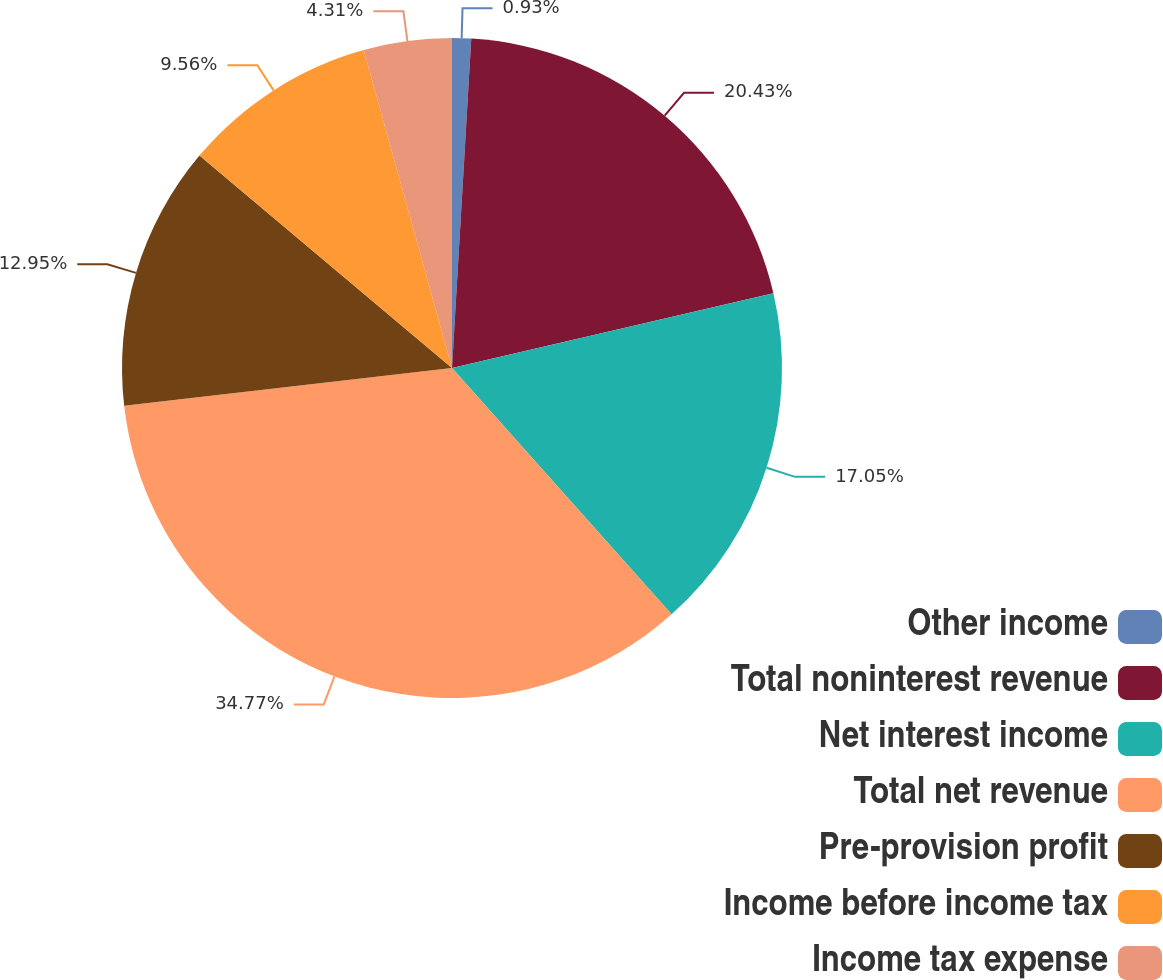<chart> <loc_0><loc_0><loc_500><loc_500><pie_chart><fcel>Other income<fcel>Total noninterest revenue<fcel>Net interest income<fcel>Total net revenue<fcel>Pre-provision profit<fcel>Income before income tax<fcel>Income tax expense<nl><fcel>0.93%<fcel>20.43%<fcel>17.05%<fcel>34.76%<fcel>12.95%<fcel>9.56%<fcel>4.31%<nl></chart> 